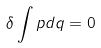Convert formula to latex. <formula><loc_0><loc_0><loc_500><loc_500>\delta \int p d q = 0</formula> 